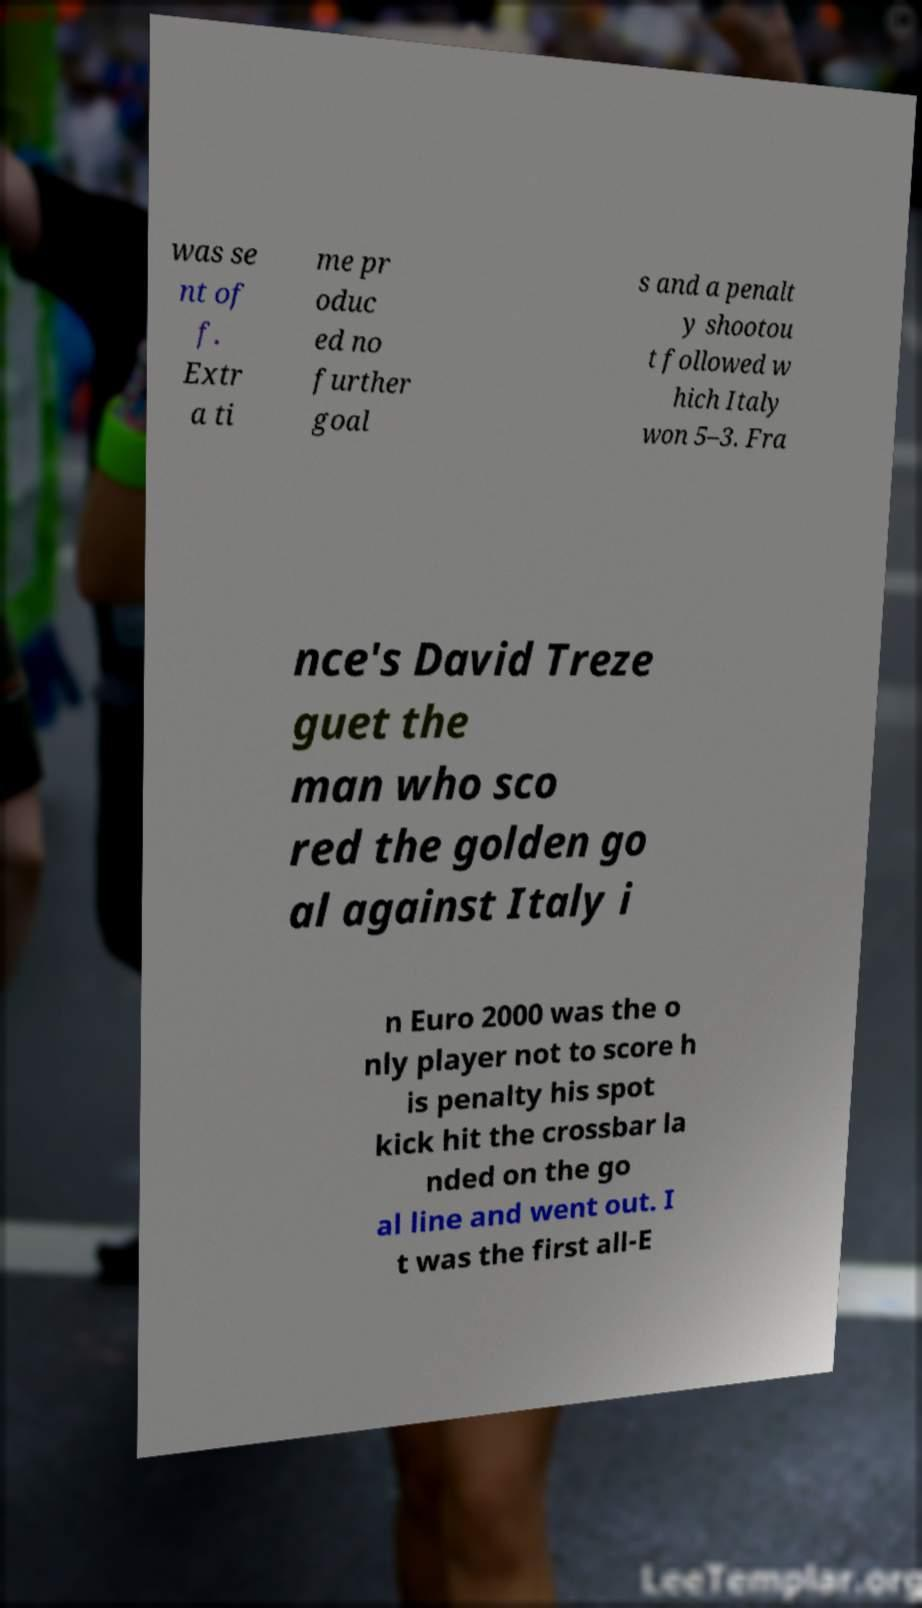Please read and relay the text visible in this image. What does it say? was se nt of f. Extr a ti me pr oduc ed no further goal s and a penalt y shootou t followed w hich Italy won 5–3. Fra nce's David Treze guet the man who sco red the golden go al against Italy i n Euro 2000 was the o nly player not to score h is penalty his spot kick hit the crossbar la nded on the go al line and went out. I t was the first all-E 